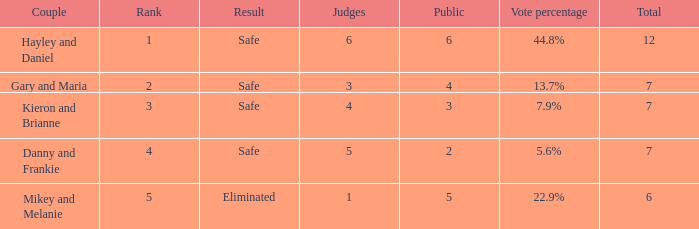Parse the table in full. {'header': ['Couple', 'Rank', 'Result', 'Judges', 'Public', 'Vote percentage', 'Total'], 'rows': [['Hayley and Daniel', '1', 'Safe', '6', '6', '44.8%', '12'], ['Gary and Maria', '2', 'Safe', '3', '4', '13.7%', '7'], ['Kieron and Brianne', '3', 'Safe', '4', '3', '7.9%', '7'], ['Danny and Frankie', '4', 'Safe', '5', '2', '5.6%', '7'], ['Mikey and Melanie', '5', 'Eliminated', '1', '5', '22.9%', '6']]} What was the total number when the vote percentage was 44.8%? 1.0. 